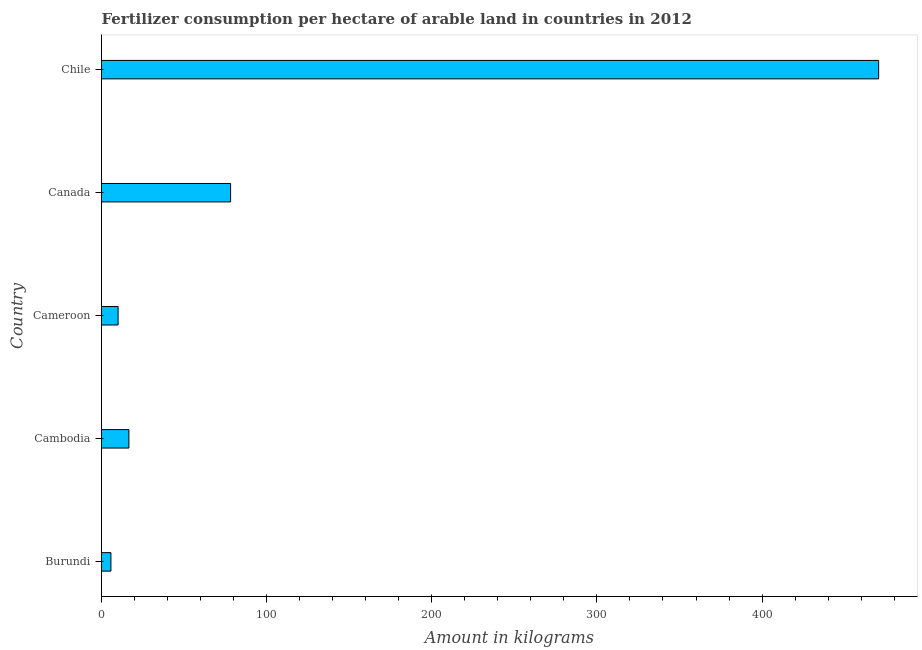Does the graph contain any zero values?
Your answer should be very brief. No. What is the title of the graph?
Provide a short and direct response. Fertilizer consumption per hectare of arable land in countries in 2012 . What is the label or title of the X-axis?
Give a very brief answer. Amount in kilograms. What is the label or title of the Y-axis?
Offer a terse response. Country. What is the amount of fertilizer consumption in Cambodia?
Your answer should be compact. 16.6. Across all countries, what is the maximum amount of fertilizer consumption?
Keep it short and to the point. 470.59. Across all countries, what is the minimum amount of fertilizer consumption?
Make the answer very short. 5.7. In which country was the amount of fertilizer consumption minimum?
Offer a very short reply. Burundi. What is the sum of the amount of fertilizer consumption?
Your answer should be compact. 581.11. What is the difference between the amount of fertilizer consumption in Burundi and Cambodia?
Keep it short and to the point. -10.9. What is the average amount of fertilizer consumption per country?
Keep it short and to the point. 116.22. What is the median amount of fertilizer consumption?
Keep it short and to the point. 16.6. In how many countries, is the amount of fertilizer consumption greater than 360 kg?
Offer a terse response. 1. What is the ratio of the amount of fertilizer consumption in Burundi to that in Cameroon?
Your answer should be very brief. 0.57. What is the difference between the highest and the second highest amount of fertilizer consumption?
Provide a short and direct response. 392.42. What is the difference between the highest and the lowest amount of fertilizer consumption?
Your response must be concise. 464.89. In how many countries, is the amount of fertilizer consumption greater than the average amount of fertilizer consumption taken over all countries?
Keep it short and to the point. 1. Are all the bars in the graph horizontal?
Offer a terse response. Yes. How many countries are there in the graph?
Make the answer very short. 5. What is the Amount in kilograms of Burundi?
Offer a terse response. 5.7. What is the Amount in kilograms in Cambodia?
Keep it short and to the point. 16.6. What is the Amount in kilograms of Cameroon?
Your answer should be compact. 10.06. What is the Amount in kilograms in Canada?
Make the answer very short. 78.17. What is the Amount in kilograms in Chile?
Your answer should be compact. 470.59. What is the difference between the Amount in kilograms in Burundi and Cambodia?
Offer a terse response. -10.9. What is the difference between the Amount in kilograms in Burundi and Cameroon?
Keep it short and to the point. -4.36. What is the difference between the Amount in kilograms in Burundi and Canada?
Keep it short and to the point. -72.47. What is the difference between the Amount in kilograms in Burundi and Chile?
Offer a terse response. -464.89. What is the difference between the Amount in kilograms in Cambodia and Cameroon?
Give a very brief answer. 6.54. What is the difference between the Amount in kilograms in Cambodia and Canada?
Offer a very short reply. -61.57. What is the difference between the Amount in kilograms in Cambodia and Chile?
Provide a succinct answer. -453.99. What is the difference between the Amount in kilograms in Cameroon and Canada?
Provide a short and direct response. -68.11. What is the difference between the Amount in kilograms in Cameroon and Chile?
Keep it short and to the point. -460.53. What is the difference between the Amount in kilograms in Canada and Chile?
Your response must be concise. -392.42. What is the ratio of the Amount in kilograms in Burundi to that in Cambodia?
Your answer should be very brief. 0.34. What is the ratio of the Amount in kilograms in Burundi to that in Cameroon?
Offer a very short reply. 0.57. What is the ratio of the Amount in kilograms in Burundi to that in Canada?
Offer a very short reply. 0.07. What is the ratio of the Amount in kilograms in Burundi to that in Chile?
Ensure brevity in your answer.  0.01. What is the ratio of the Amount in kilograms in Cambodia to that in Cameroon?
Offer a terse response. 1.65. What is the ratio of the Amount in kilograms in Cambodia to that in Canada?
Your answer should be very brief. 0.21. What is the ratio of the Amount in kilograms in Cambodia to that in Chile?
Make the answer very short. 0.04. What is the ratio of the Amount in kilograms in Cameroon to that in Canada?
Offer a terse response. 0.13. What is the ratio of the Amount in kilograms in Cameroon to that in Chile?
Your answer should be compact. 0.02. What is the ratio of the Amount in kilograms in Canada to that in Chile?
Keep it short and to the point. 0.17. 